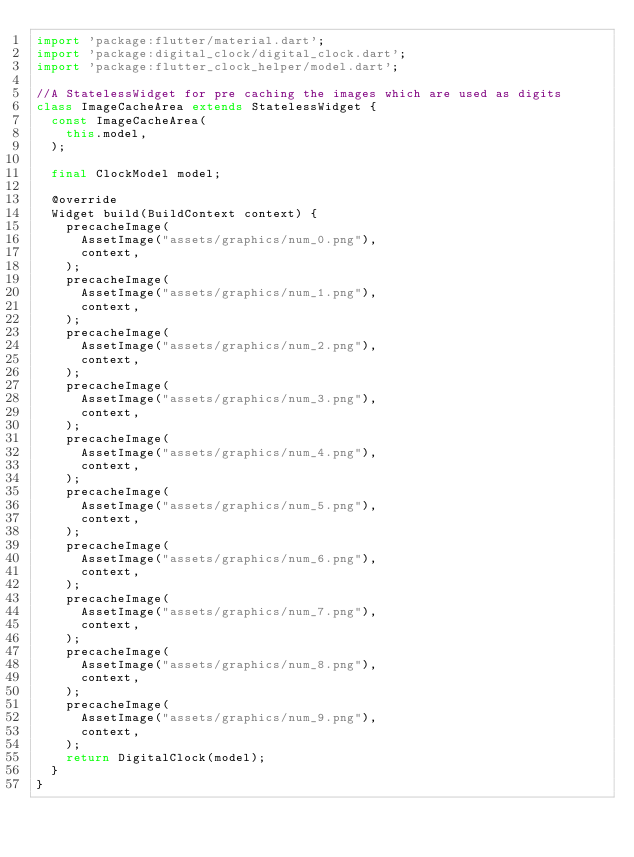<code> <loc_0><loc_0><loc_500><loc_500><_Dart_>import 'package:flutter/material.dart';
import 'package:digital_clock/digital_clock.dart';
import 'package:flutter_clock_helper/model.dart';

//A StatelessWidget for pre caching the images which are used as digits
class ImageCacheArea extends StatelessWidget {
  const ImageCacheArea(
    this.model,
  );

  final ClockModel model;

  @override
  Widget build(BuildContext context) {
    precacheImage(
      AssetImage("assets/graphics/num_0.png"),
      context,
    );
    precacheImage(
      AssetImage("assets/graphics/num_1.png"),
      context,
    );
    precacheImage(
      AssetImage("assets/graphics/num_2.png"),
      context,
    );
    precacheImage(
      AssetImage("assets/graphics/num_3.png"),
      context,
    );
    precacheImage(
      AssetImage("assets/graphics/num_4.png"),
      context,
    );
    precacheImage(
      AssetImage("assets/graphics/num_5.png"),
      context,
    );
    precacheImage(
      AssetImage("assets/graphics/num_6.png"),
      context,
    );
    precacheImage(
      AssetImage("assets/graphics/num_7.png"),
      context,
    );
    precacheImage(
      AssetImage("assets/graphics/num_8.png"),
      context,
    );
    precacheImage(
      AssetImage("assets/graphics/num_9.png"),
      context,
    );
    return DigitalClock(model);
  }
}
</code> 